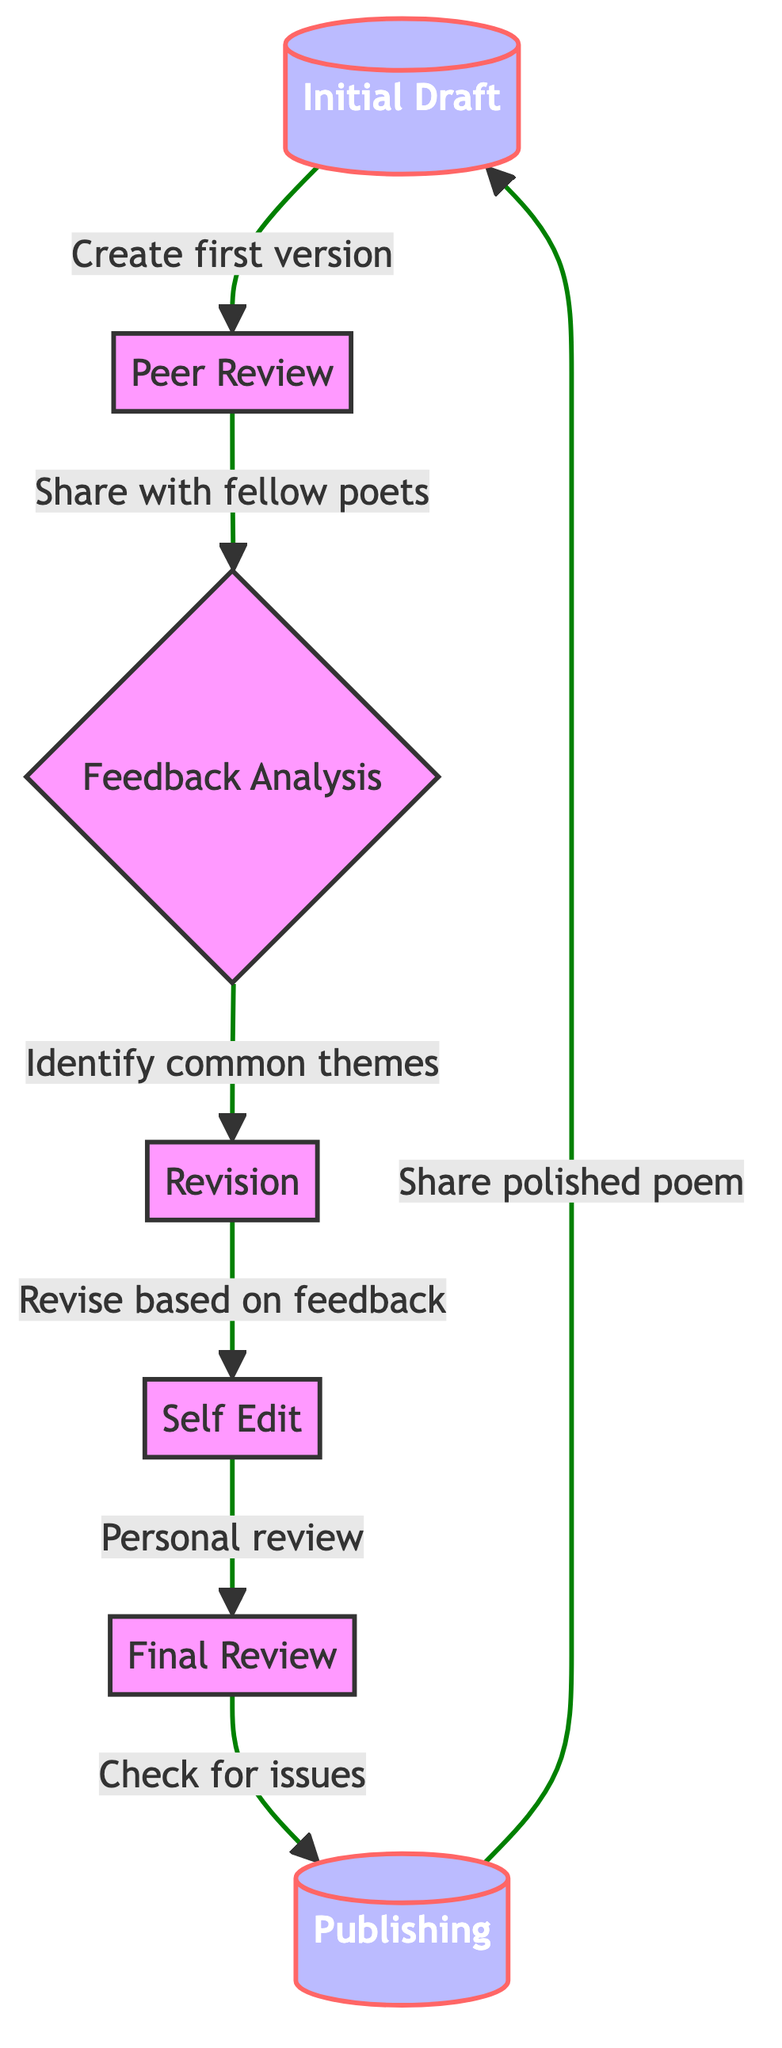What is the first step in the feedback loop process? The diagram starts with "Initial Draft," indicating that creating the first version of the poem is where the process begins.
Answer: Initial Draft How many steps are there in the feedback loop process? The diagram shows a total of six unique nodes in the feedback process: Initial Draft, Peer Review, Feedback Analysis, Revision, Self Edit, Final Review, and Publishing. Therefore, there are seven steps.
Answer: 7 What is the next step after "Self Edit"? From the diagram, the flow indicates that after "Self Edit," the next step is "Final Review."
Answer: Final Review Which step involves sharing the poem with fellow poets? The node titled "Peer Review" directly mentions sharing the poem with fellow poets for feedback, making it the step that involves this action.
Answer: Peer Review What is the last step before returning to the initial draft in the process? According to the flow chart, the final step before going back to the "Initial Draft" is "Publishing," which shows that the polished poem is shared before the process starts over.
Answer: Publishing What step follows "Feedback Analysis"? The diagram specifies that after "Feedback Analysis," the next step taken is "Revision." This illustrates the sequence of actions following feedback.
Answer: Revision Which two steps are separated by the "Self Edit" node? The diagram indicates that "Self Edit" is preceded by "Revision" and followed by "Final Review," therefore these are the two steps around it in the process.
Answer: Revision and Final Review What action occurs during the "Feedback Analysis" step? The "Feedback Analysis" step is concerned with analyzing the received feedback and identifying common themes, which is indicated in the description in the diagram.
Answer: Analyze feedback and identify themes What ensures the poem is polished before publishing? The step called "Final Review" includes performing a final check for grammatical or structural issues to ensure that the poem is polished before the publishing step.
Answer: Final Review 